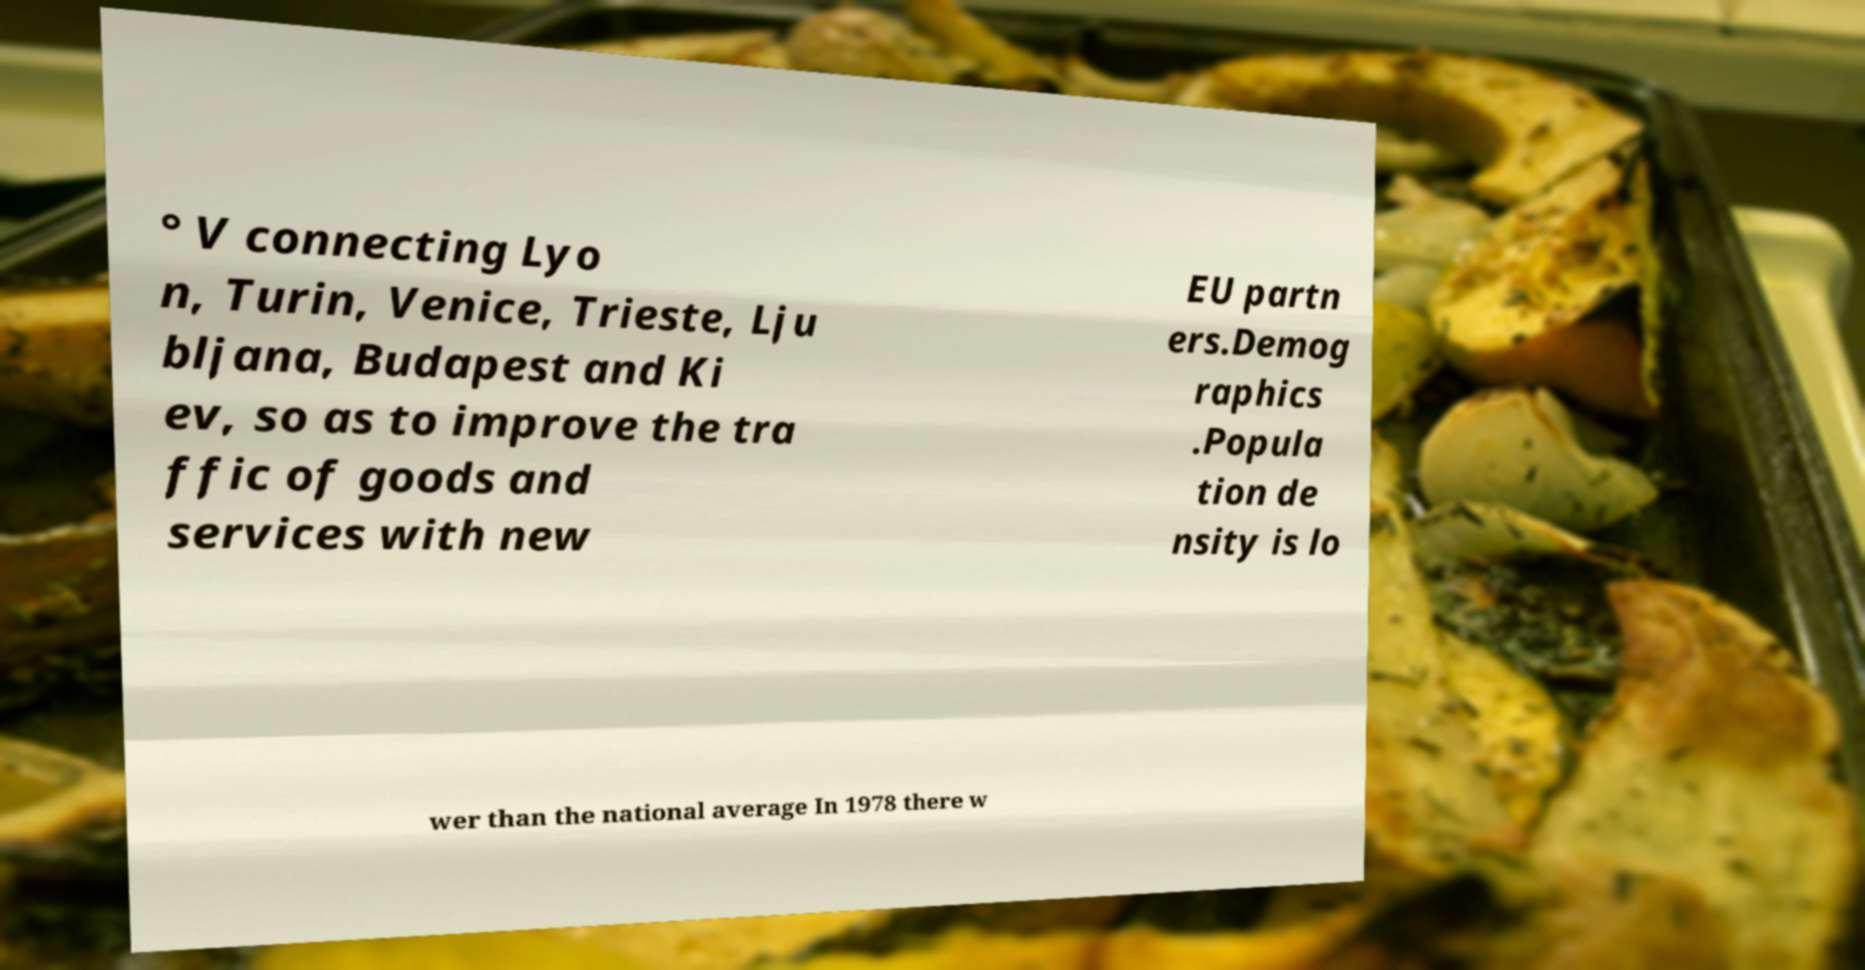Could you extract and type out the text from this image? ° V connecting Lyo n, Turin, Venice, Trieste, Lju bljana, Budapest and Ki ev, so as to improve the tra ffic of goods and services with new EU partn ers.Demog raphics .Popula tion de nsity is lo wer than the national average In 1978 there w 